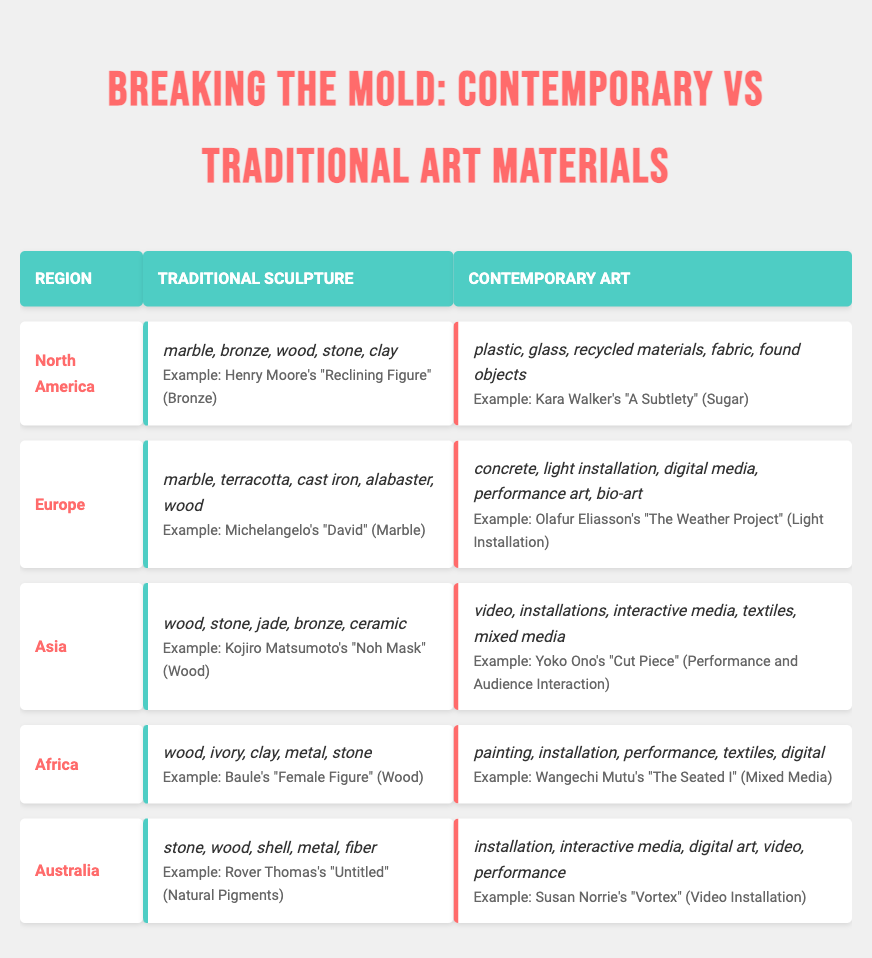What materials are used in traditional sculpture from North America? The table lists the materials for traditional sculpture in North America as marble, bronze, wood, stone, and clay. These materials are explicitly stated under the "Traditional Sculpture" section for the North America region.
Answer: marble, bronze, wood, stone, clay Which region uses jade in their traditional sculptures? The region listed in the table that includes jade as one of the materials for traditional sculpture is Asia. This is found under the "Traditional Sculpture" section for Asia.
Answer: Asia How many materials are listed for contemporary art in Europe? In the table, Europe has five materials listed for contemporary art: concrete, light installation, digital media, performance art, and bio-art. To arrive at this number, simply count the materials listed in the "Contemporary Art" section for Europe.
Answer: 5 Does traditional sculpture in Africa include ivory as a material? The table specifies that traditional sculpture in Africa includes ivory as one of the listed materials, confirming the presence of ivory in this category.
Answer: Yes Which region has the most diversity in contemporary art materials based on the displayed list? By comparing the number of different materials listed in the "Contemporary Art" columns across regions, all regions have five materials listed, so they share the same level of diversity. This requires evaluating all contemporary art materials presented in the table.
Answer: All regions have equal diversity What is the difference in the number of materials between traditional sculpture in Australia and contemporary art in Africa? Traditional sculpture in Australia has five materials: stone, wood, shell, metal, and fiber. Contemporary art in Africa has five materials as well: painting, installation, performance, textiles, and digital. Therefore, the difference is computed as 5 - 5 = 0.
Answer: 0 Who is the artist behind the work "The Flying Lady"? The table mentions Yinka Shonibare as the artist of "The Flying Lady," which is categorized under the contemporary art section for Africa. This can be directly found in the corresponding example given.
Answer: Yinka Shonibare What material is used by Olafur Eliasson in his contemporary art piece listed in Europe? The artwork "The Weather Project" by Olafur Eliasson is listed under contemporary art in Europe, with the material being a light installation, as detailed in the examples provided in the table.
Answer: Light Installation Which artist is associated with "The Gates" and what material was used? "The Gates" is associated with the artist Christo and Jeanne-Claude, and the material used for this artwork is fabric. This information is found in the contemporary art section for North America under the examples provided.
Answer: Christo and Jeanne-Claude, Fabric How many different materials are used in traditional sculpture across all regions? A total of five regions are listed, each having a diverse set of materials, summing up to 5 (North America) + 5 (Europe) + 5 (Asia) + 5 (Africa) + 5 (Australia) = 25 total different material mentions. However, some materials might be repeated across regions, requiring a deeper analysis of unique materials might reveal a lesser number. But from the surface-level examination, there are 25 mentions.
Answer: 25 (with potential duplicates) 